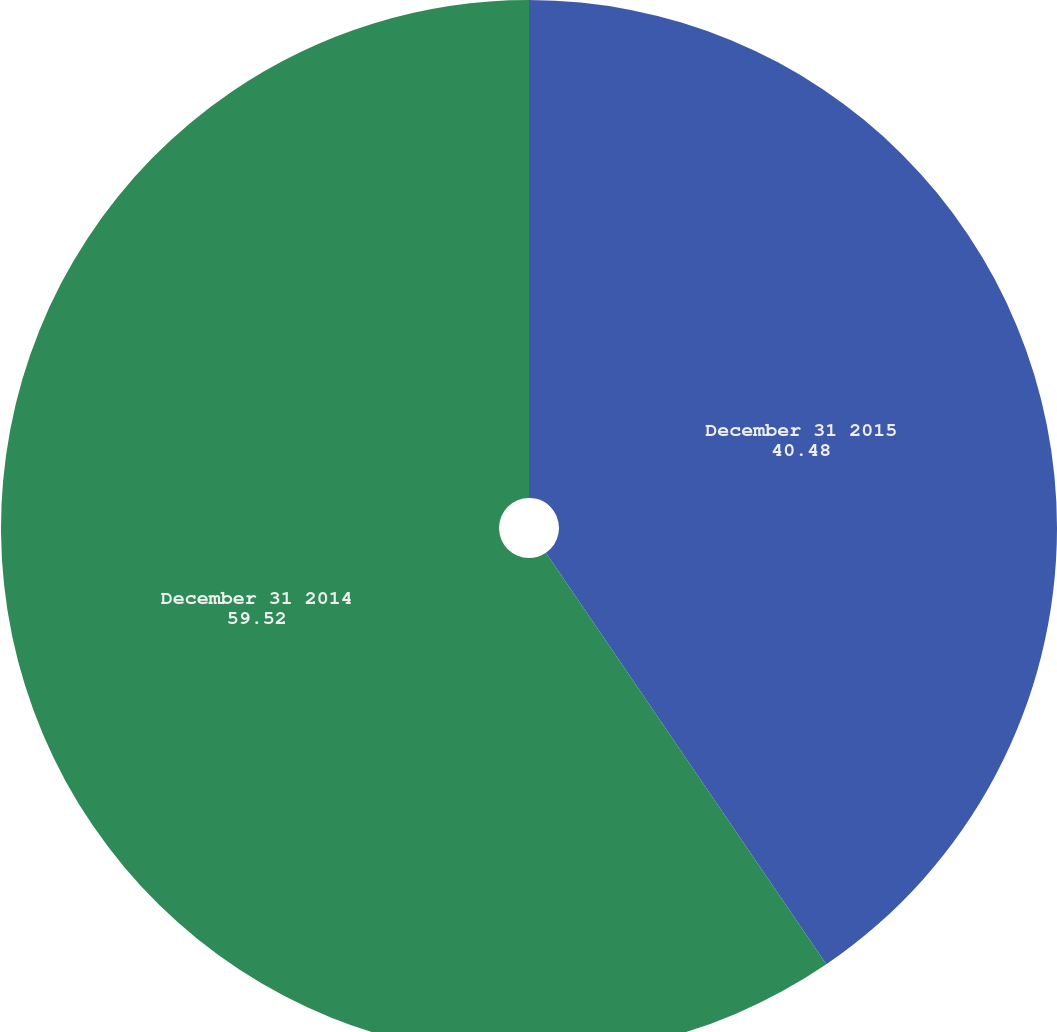Convert chart to OTSL. <chart><loc_0><loc_0><loc_500><loc_500><pie_chart><fcel>December 31 2015<fcel>December 31 2014<nl><fcel>40.48%<fcel>59.52%<nl></chart> 